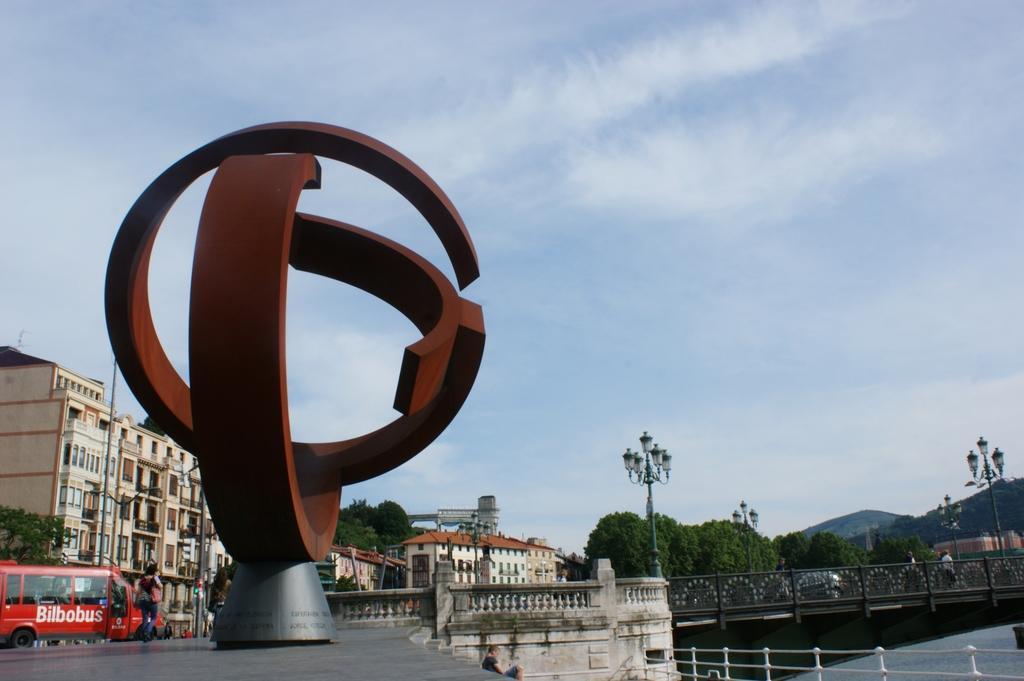Please provide a concise description of this image. In front of the image there is a metal structure, in the background of the image there are buildings and trees and there is a bus passing on to the bridge, beneath the bridge there is water, in the background of the image there are mountains. 